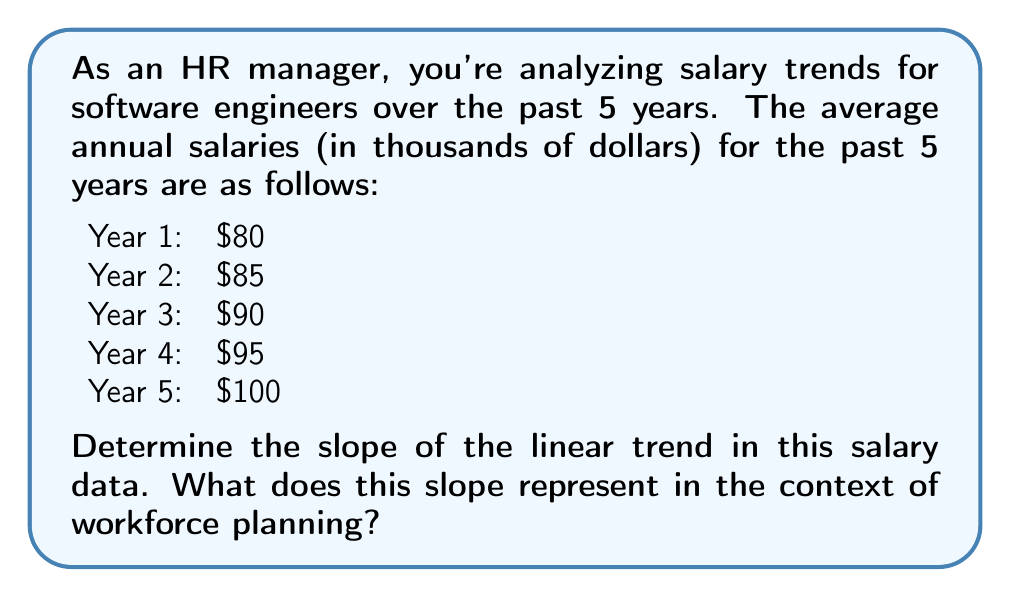Solve this math problem. To find the slope of the linear trend in salary data, we'll use the formula for slope:

$$ m = \frac{y_2 - y_1}{x_2 - x_1} $$

Where:
- $m$ is the slope
- $(x_1, y_1)$ is a point on the line (we'll use the first data point)
- $(x_2, y_2)$ is another point on the line (we'll use the last data point)

Let's define our points:
- $(x_1, y_1) = (1, 80)$ (Year 1, $80,000)
- $(x_2, y_2) = (5, 100)$ (Year 5, $100,000)

Now, let's substitute these values into the slope formula:

$$ m = \frac{100 - 80}{5 - 1} = \frac{20}{4} = 5 $$

The slope is 5, which means the salary is increasing by $5,000 per year on average.

In the context of workforce planning, this slope represents:

1. The average annual salary increase for software engineers over the past 5 years.
2. A trend that can be used to project future salaries if market conditions remain similar.
3. A benchmark for setting competitive salary increases to attract and retain talent.
4. An indicator of the rising cost of labor in this job category, which is crucial for budgeting and financial planning.
Answer: The slope of the linear trend in the salary data is 5, representing an average annual salary increase of $5,000 for software engineers over the past 5 years. 